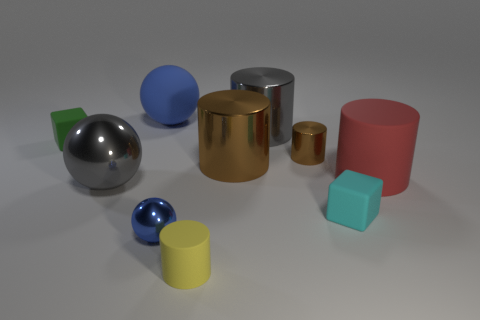How many objects have a matte surface? Five objects exhibit a matte surface: the large red and blue cylinders, the tiny blue sphere, and the two cubes, one teal and the other yellow. Can you describe the positions of the cubes? Certainly! The teal cube is to the left side of the image, near the blue sphere and yellow cylinder. The yellow cube is on the right, positioned in front of the smaller gold cylinder. 